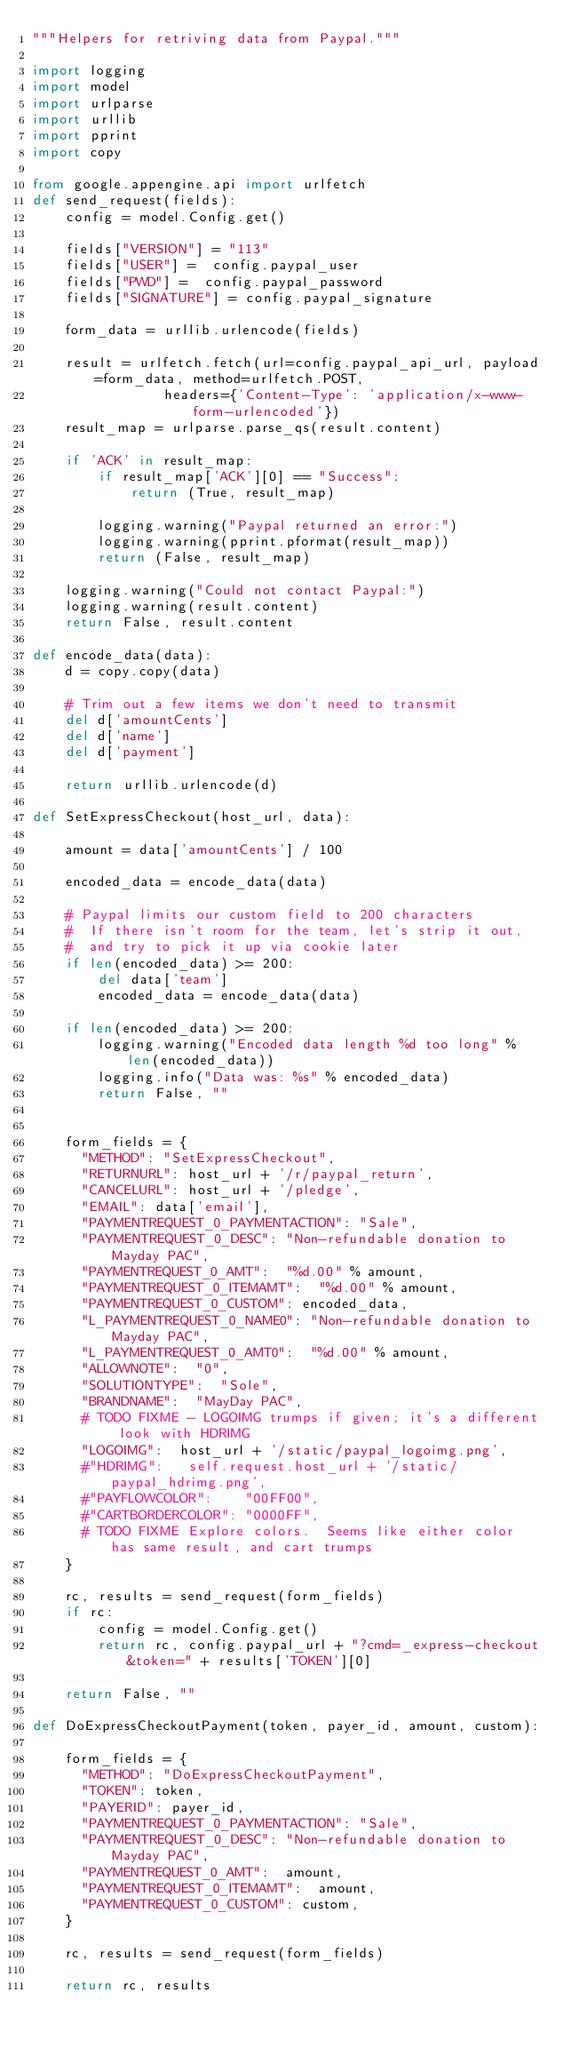<code> <loc_0><loc_0><loc_500><loc_500><_Python_>"""Helpers for retriving data from Paypal."""

import logging
import model
import urlparse
import urllib
import pprint
import copy

from google.appengine.api import urlfetch
def send_request(fields):
    config = model.Config.get()

    fields["VERSION"] = "113"
    fields["USER"] =  config.paypal_user
    fields["PWD"] =  config.paypal_password
    fields["SIGNATURE"] = config.paypal_signature

    form_data = urllib.urlencode(fields)

    result = urlfetch.fetch(url=config.paypal_api_url, payload=form_data, method=urlfetch.POST,
                headers={'Content-Type': 'application/x-www-form-urlencoded'})
    result_map = urlparse.parse_qs(result.content)

    if 'ACK' in result_map:
        if result_map['ACK'][0] == "Success":
            return (True, result_map)
   
        logging.warning("Paypal returned an error:")
        logging.warning(pprint.pformat(result_map))
        return (False, result_map)

    logging.warning("Could not contact Paypal:")
    logging.warning(result.content)
    return False, result.content

def encode_data(data):
    d = copy.copy(data)

    # Trim out a few items we don't need to transmit
    del d['amountCents']
    del d['name']
    del d['payment']

    return urllib.urlencode(d)

def SetExpressCheckout(host_url, data):

    amount = data['amountCents'] / 100

    encoded_data = encode_data(data)

    # Paypal limits our custom field to 200 characters
    #  If there isn't room for the team, let's strip it out,
    #  and try to pick it up via cookie later
    if len(encoded_data) >= 200:      
        del data['team']
        encoded_data = encode_data(data)

    if len(encoded_data) >= 200:
        logging.warning("Encoded data length %d too long" % len(encoded_data))
        logging.info("Data was: %s" % encoded_data)
        return False, ""


    form_fields = {
      "METHOD": "SetExpressCheckout",
      "RETURNURL": host_url + '/r/paypal_return',
      "CANCELURL": host_url + '/pledge',
      "EMAIL": data['email'],
      "PAYMENTREQUEST_0_PAYMENTACTION": "Sale",
      "PAYMENTREQUEST_0_DESC": "Non-refundable donation to Mayday PAC",
      "PAYMENTREQUEST_0_AMT":  "%d.00" % amount,
      "PAYMENTREQUEST_0_ITEMAMT":  "%d.00" % amount,
      "PAYMENTREQUEST_0_CUSTOM": encoded_data,
      "L_PAYMENTREQUEST_0_NAME0": "Non-refundable donation to Mayday PAC",
      "L_PAYMENTREQUEST_0_AMT0":  "%d.00" % amount,
      "ALLOWNOTE":  "0",
      "SOLUTIONTYPE":  "Sole",
      "BRANDNAME":  "MayDay PAC",
      # TODO FIXME - LOGOIMG trumps if given; it's a different look with HDRIMG
      "LOGOIMG":  host_url + '/static/paypal_logoimg.png',
      #"HDRIMG":   self.request.host_url + '/static/paypal_hdrimg.png',
      #"PAYFLOWCOLOR":    "00FF00",
      #"CARTBORDERCOLOR": "0000FF",
      # TODO FIXME Explore colors.  Seems like either color has same result, and cart trumps
    }

    rc, results = send_request(form_fields)
    if rc:
        config = model.Config.get()
        return rc, config.paypal_url + "?cmd=_express-checkout&token=" + results['TOKEN'][0]

    return False, ""

def DoExpressCheckoutPayment(token, payer_id, amount, custom):

    form_fields = {
      "METHOD": "DoExpressCheckoutPayment",
      "TOKEN": token,
      "PAYERID": payer_id,
      "PAYMENTREQUEST_0_PAYMENTACTION": "Sale",
      "PAYMENTREQUEST_0_DESC": "Non-refundable donation to Mayday PAC",
      "PAYMENTREQUEST_0_AMT":  amount,
      "PAYMENTREQUEST_0_ITEMAMT":  amount,
      "PAYMENTREQUEST_0_CUSTOM": custom,
    }

    rc, results = send_request(form_fields)

    return rc, results

</code> 